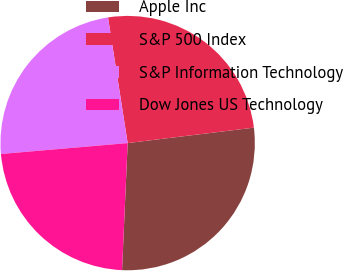Convert chart. <chart><loc_0><loc_0><loc_500><loc_500><pie_chart><fcel>Apple Inc<fcel>S&P 500 Index<fcel>S&P Information Technology<fcel>Dow Jones US Technology<nl><fcel>27.64%<fcel>25.53%<fcel>23.9%<fcel>22.93%<nl></chart> 